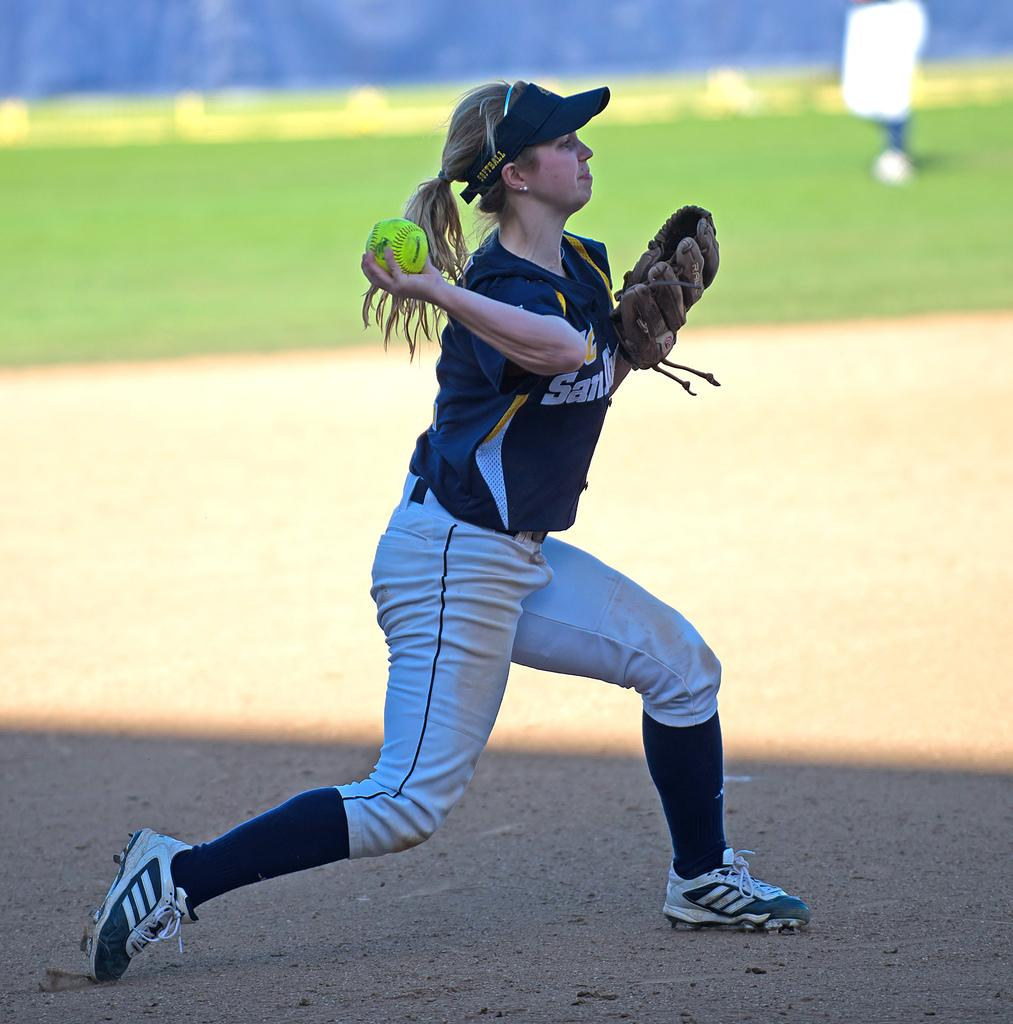<image>
Present a compact description of the photo's key features. A girl with a San Diego baseball team throws a ball. 